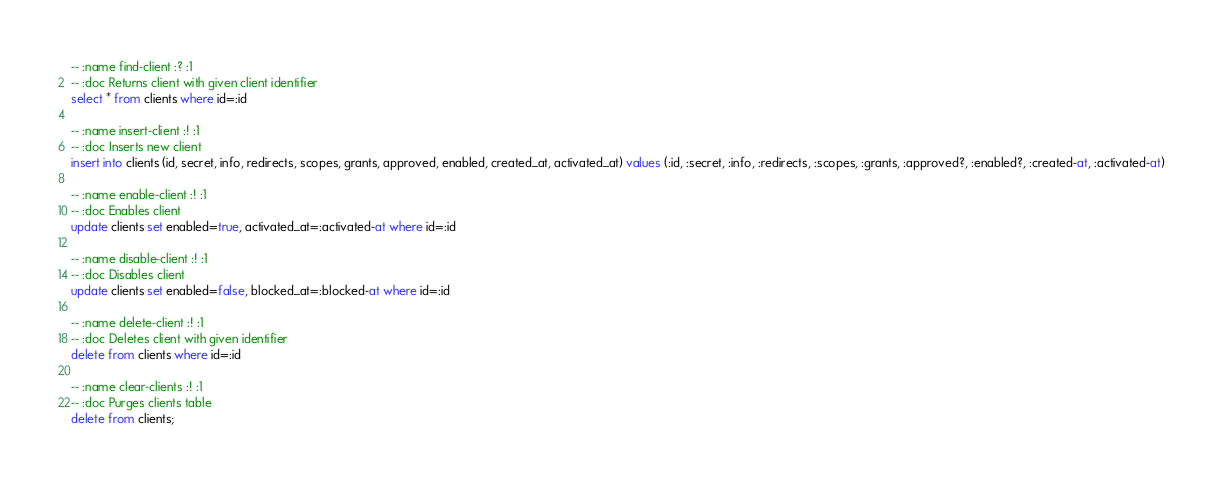Convert code to text. <code><loc_0><loc_0><loc_500><loc_500><_SQL_>-- :name find-client :? :1
-- :doc Returns client with given client identifier
select * from clients where id=:id

-- :name insert-client :! :1
-- :doc Inserts new client
insert into clients (id, secret, info, redirects, scopes, grants, approved, enabled, created_at, activated_at) values (:id, :secret, :info, :redirects, :scopes, :grants, :approved?, :enabled?, :created-at, :activated-at)

-- :name enable-client :! :1
-- :doc Enables client
update clients set enabled=true, activated_at=:activated-at where id=:id

-- :name disable-client :! :1
-- :doc Disables client
update clients set enabled=false, blocked_at=:blocked-at where id=:id

-- :name delete-client :! :1
-- :doc Deletes client with given identifier
delete from clients where id=:id

-- :name clear-clients :! :1
-- :doc Purges clients table
delete from clients;
</code> 